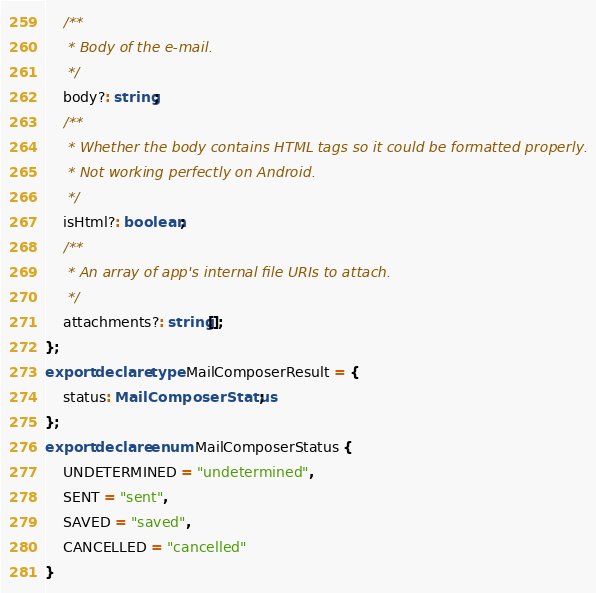Convert code to text. <code><loc_0><loc_0><loc_500><loc_500><_TypeScript_>    /**
     * Body of the e-mail.
     */
    body?: string;
    /**
     * Whether the body contains HTML tags so it could be formatted properly.
     * Not working perfectly on Android.
     */
    isHtml?: boolean;
    /**
     * An array of app's internal file URIs to attach.
     */
    attachments?: string[];
};
export declare type MailComposerResult = {
    status: MailComposerStatus;
};
export declare enum MailComposerStatus {
    UNDETERMINED = "undetermined",
    SENT = "sent",
    SAVED = "saved",
    CANCELLED = "cancelled"
}
</code> 